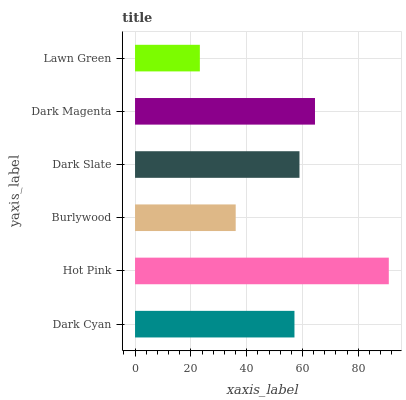Is Lawn Green the minimum?
Answer yes or no. Yes. Is Hot Pink the maximum?
Answer yes or no. Yes. Is Burlywood the minimum?
Answer yes or no. No. Is Burlywood the maximum?
Answer yes or no. No. Is Hot Pink greater than Burlywood?
Answer yes or no. Yes. Is Burlywood less than Hot Pink?
Answer yes or no. Yes. Is Burlywood greater than Hot Pink?
Answer yes or no. No. Is Hot Pink less than Burlywood?
Answer yes or no. No. Is Dark Slate the high median?
Answer yes or no. Yes. Is Dark Cyan the low median?
Answer yes or no. Yes. Is Burlywood the high median?
Answer yes or no. No. Is Dark Magenta the low median?
Answer yes or no. No. 